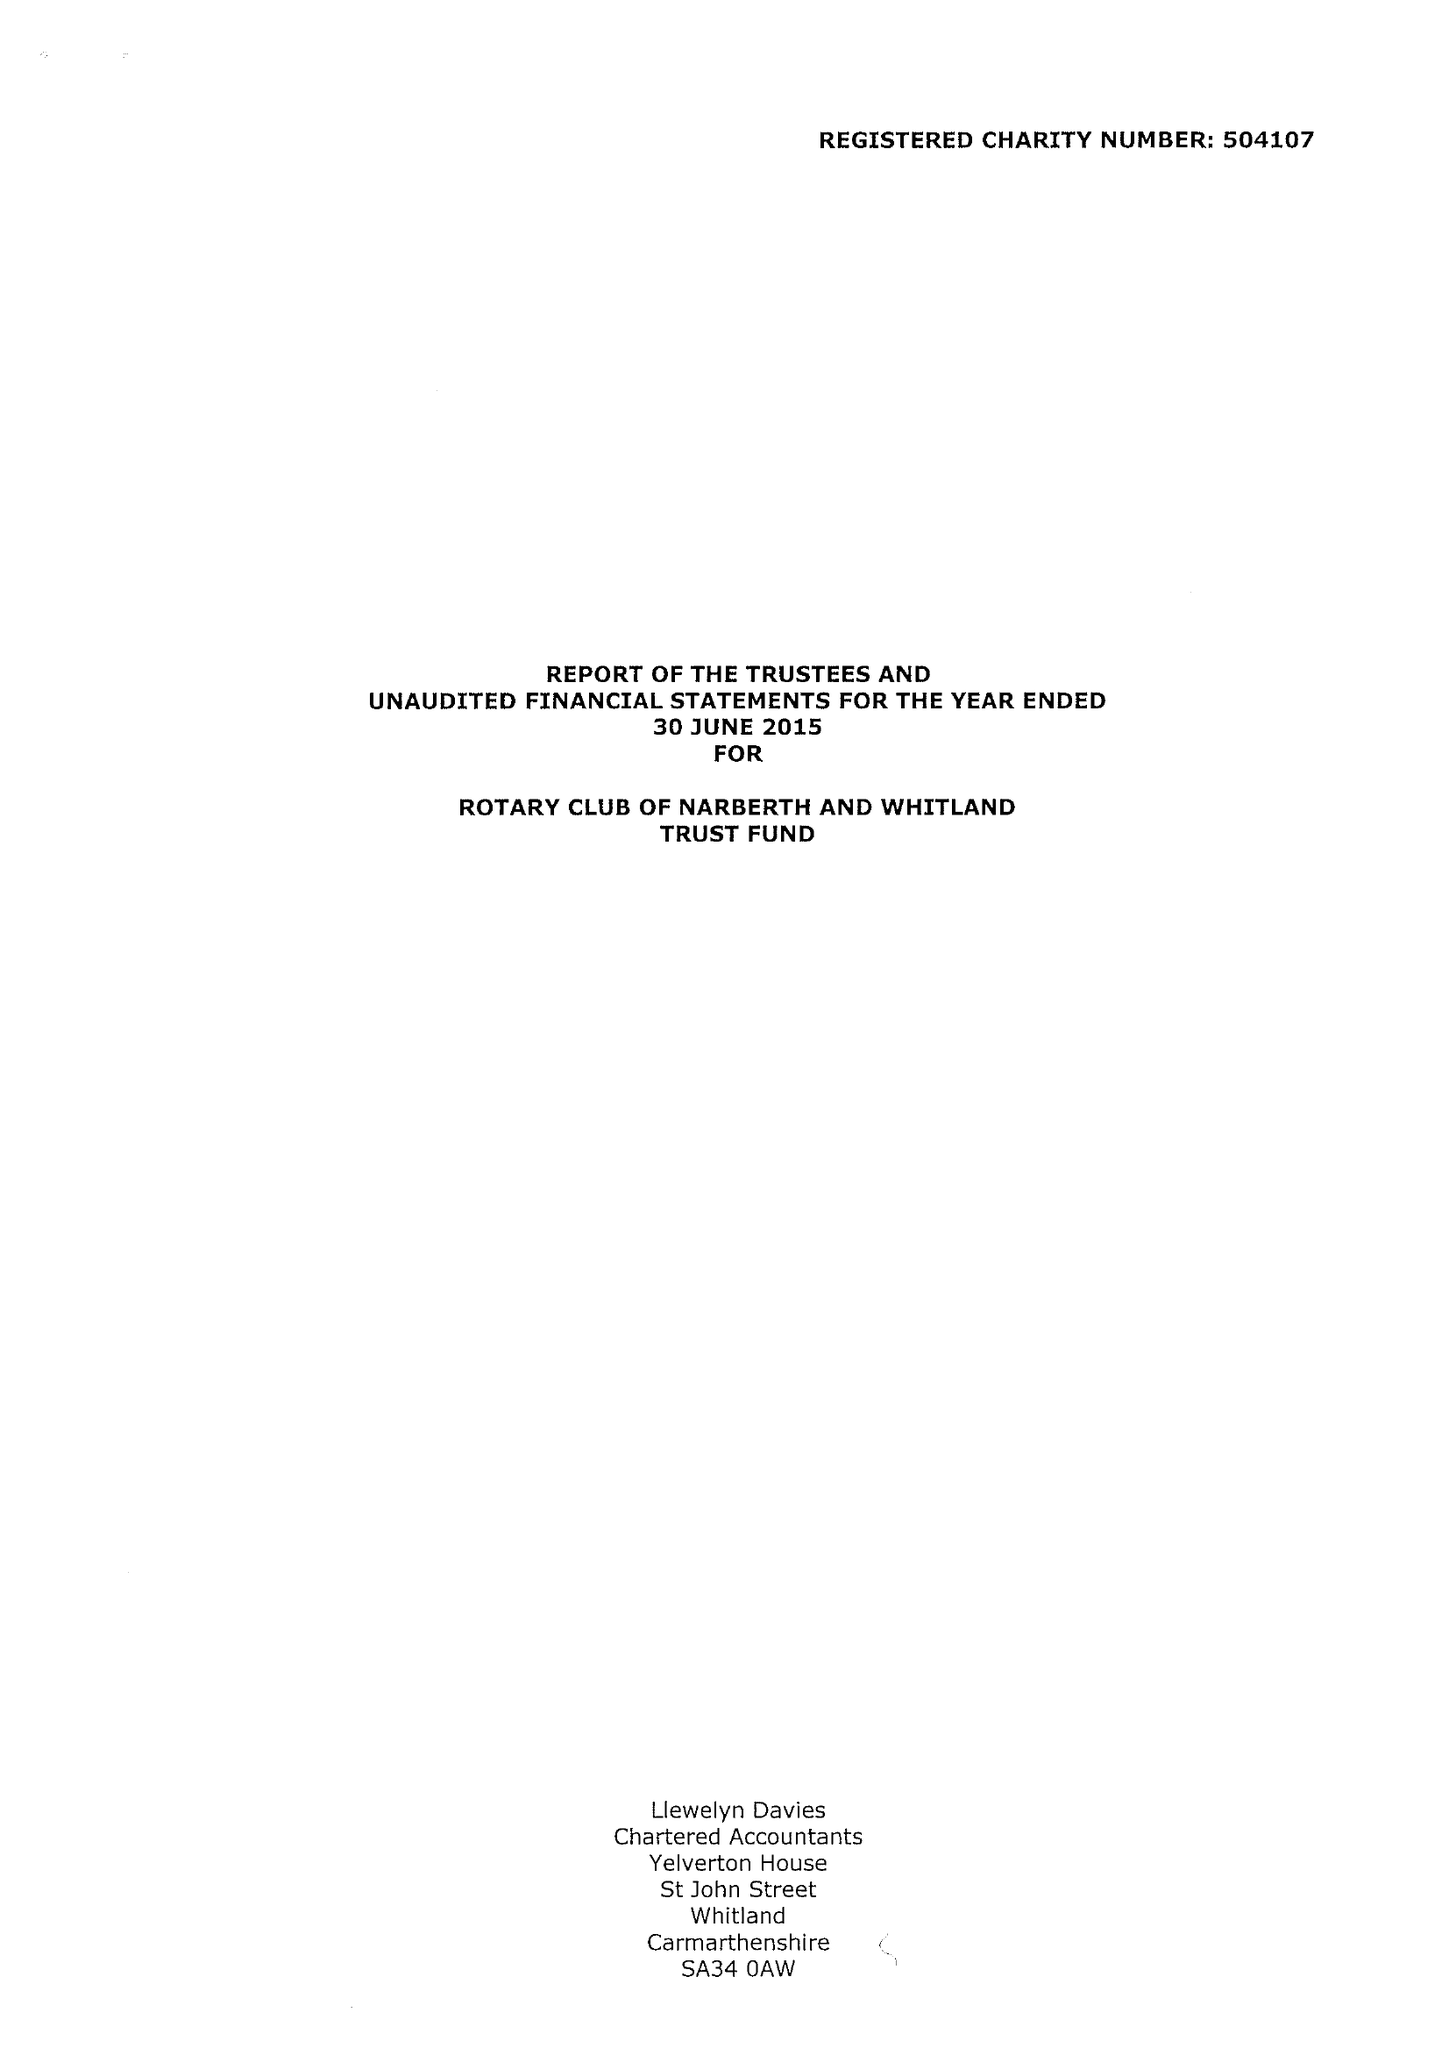What is the value for the address__postcode?
Answer the question using a single word or phrase. SA67 8RP 